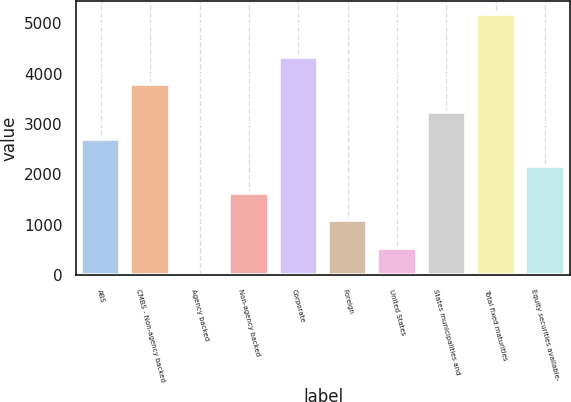<chart> <loc_0><loc_0><loc_500><loc_500><bar_chart><fcel>ABS<fcel>CMBS - Non-agency backed<fcel>Agency backed<fcel>Non-agency backed<fcel>Corporate<fcel>Foreign<fcel>United States<fcel>States municipalities and<fcel>Total fixed maturities<fcel>Equity securities available-<nl><fcel>2704<fcel>3782.8<fcel>7<fcel>1625.2<fcel>4322.2<fcel>1085.8<fcel>546.4<fcel>3243.4<fcel>5180<fcel>2164.6<nl></chart> 